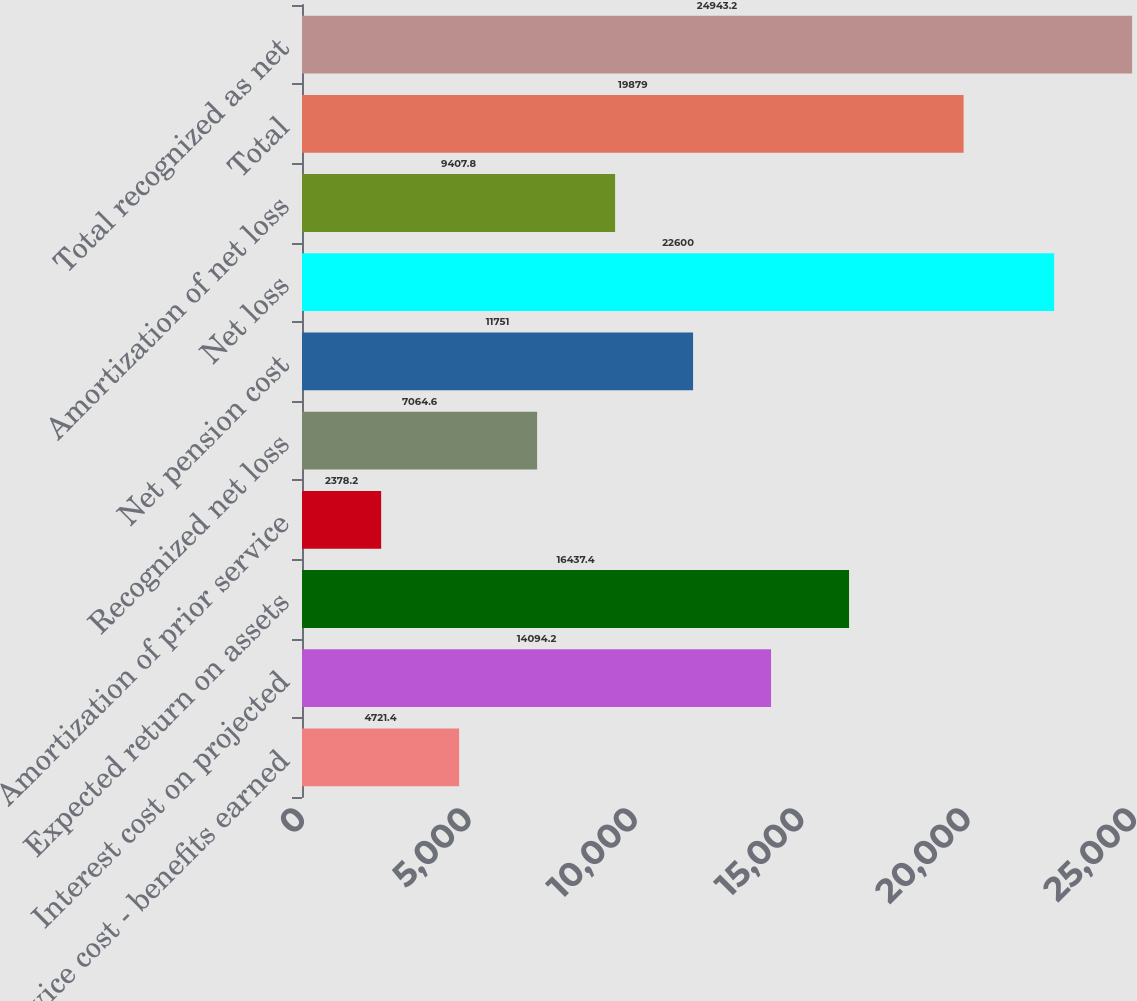Convert chart. <chart><loc_0><loc_0><loc_500><loc_500><bar_chart><fcel>Service cost - benefits earned<fcel>Interest cost on projected<fcel>Expected return on assets<fcel>Amortization of prior service<fcel>Recognized net loss<fcel>Net pension cost<fcel>Net loss<fcel>Amortization of net loss<fcel>Total<fcel>Total recognized as net<nl><fcel>4721.4<fcel>14094.2<fcel>16437.4<fcel>2378.2<fcel>7064.6<fcel>11751<fcel>22600<fcel>9407.8<fcel>19879<fcel>24943.2<nl></chart> 